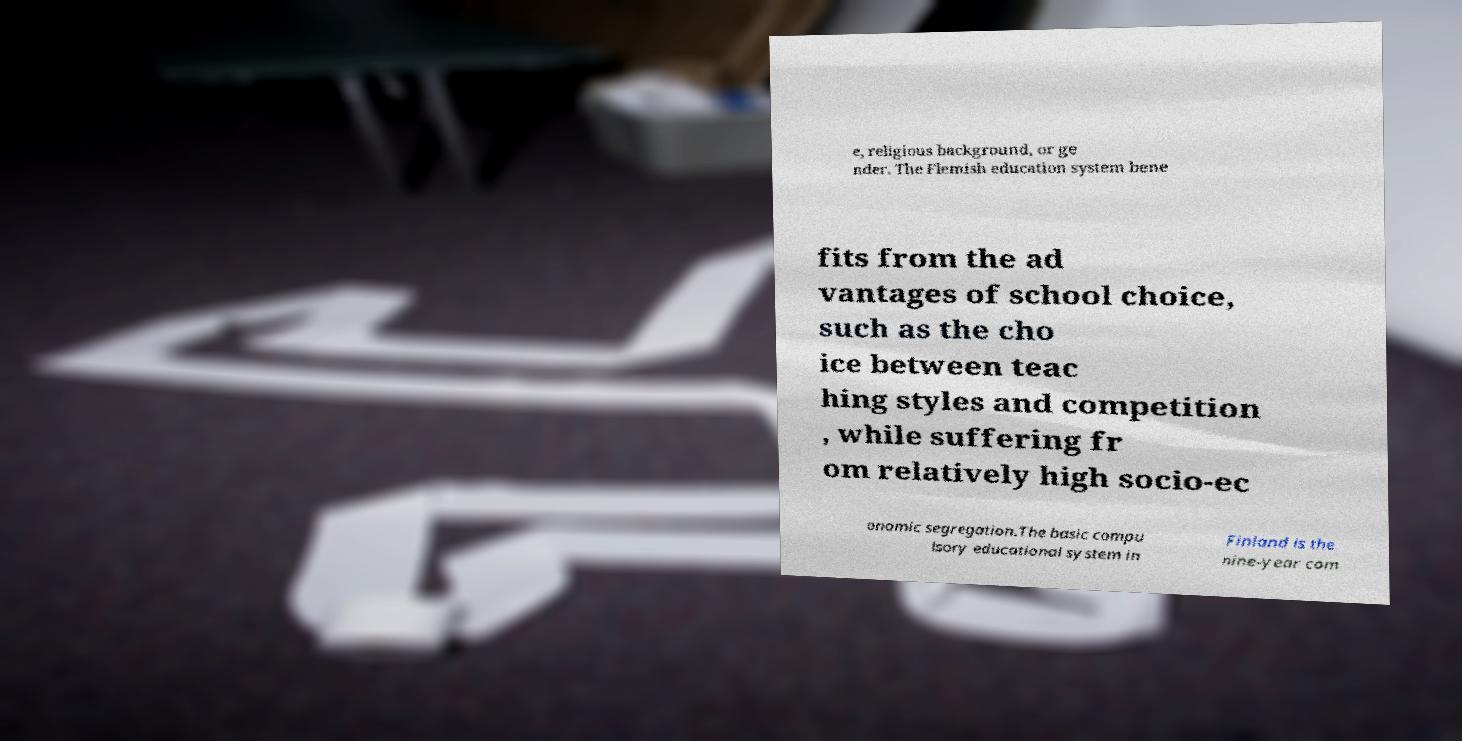Can you accurately transcribe the text from the provided image for me? e, religious background, or ge nder. The Flemish education system bene fits from the ad vantages of school choice, such as the cho ice between teac hing styles and competition , while suffering fr om relatively high socio-ec onomic segregation.The basic compu lsory educational system in Finland is the nine-year com 